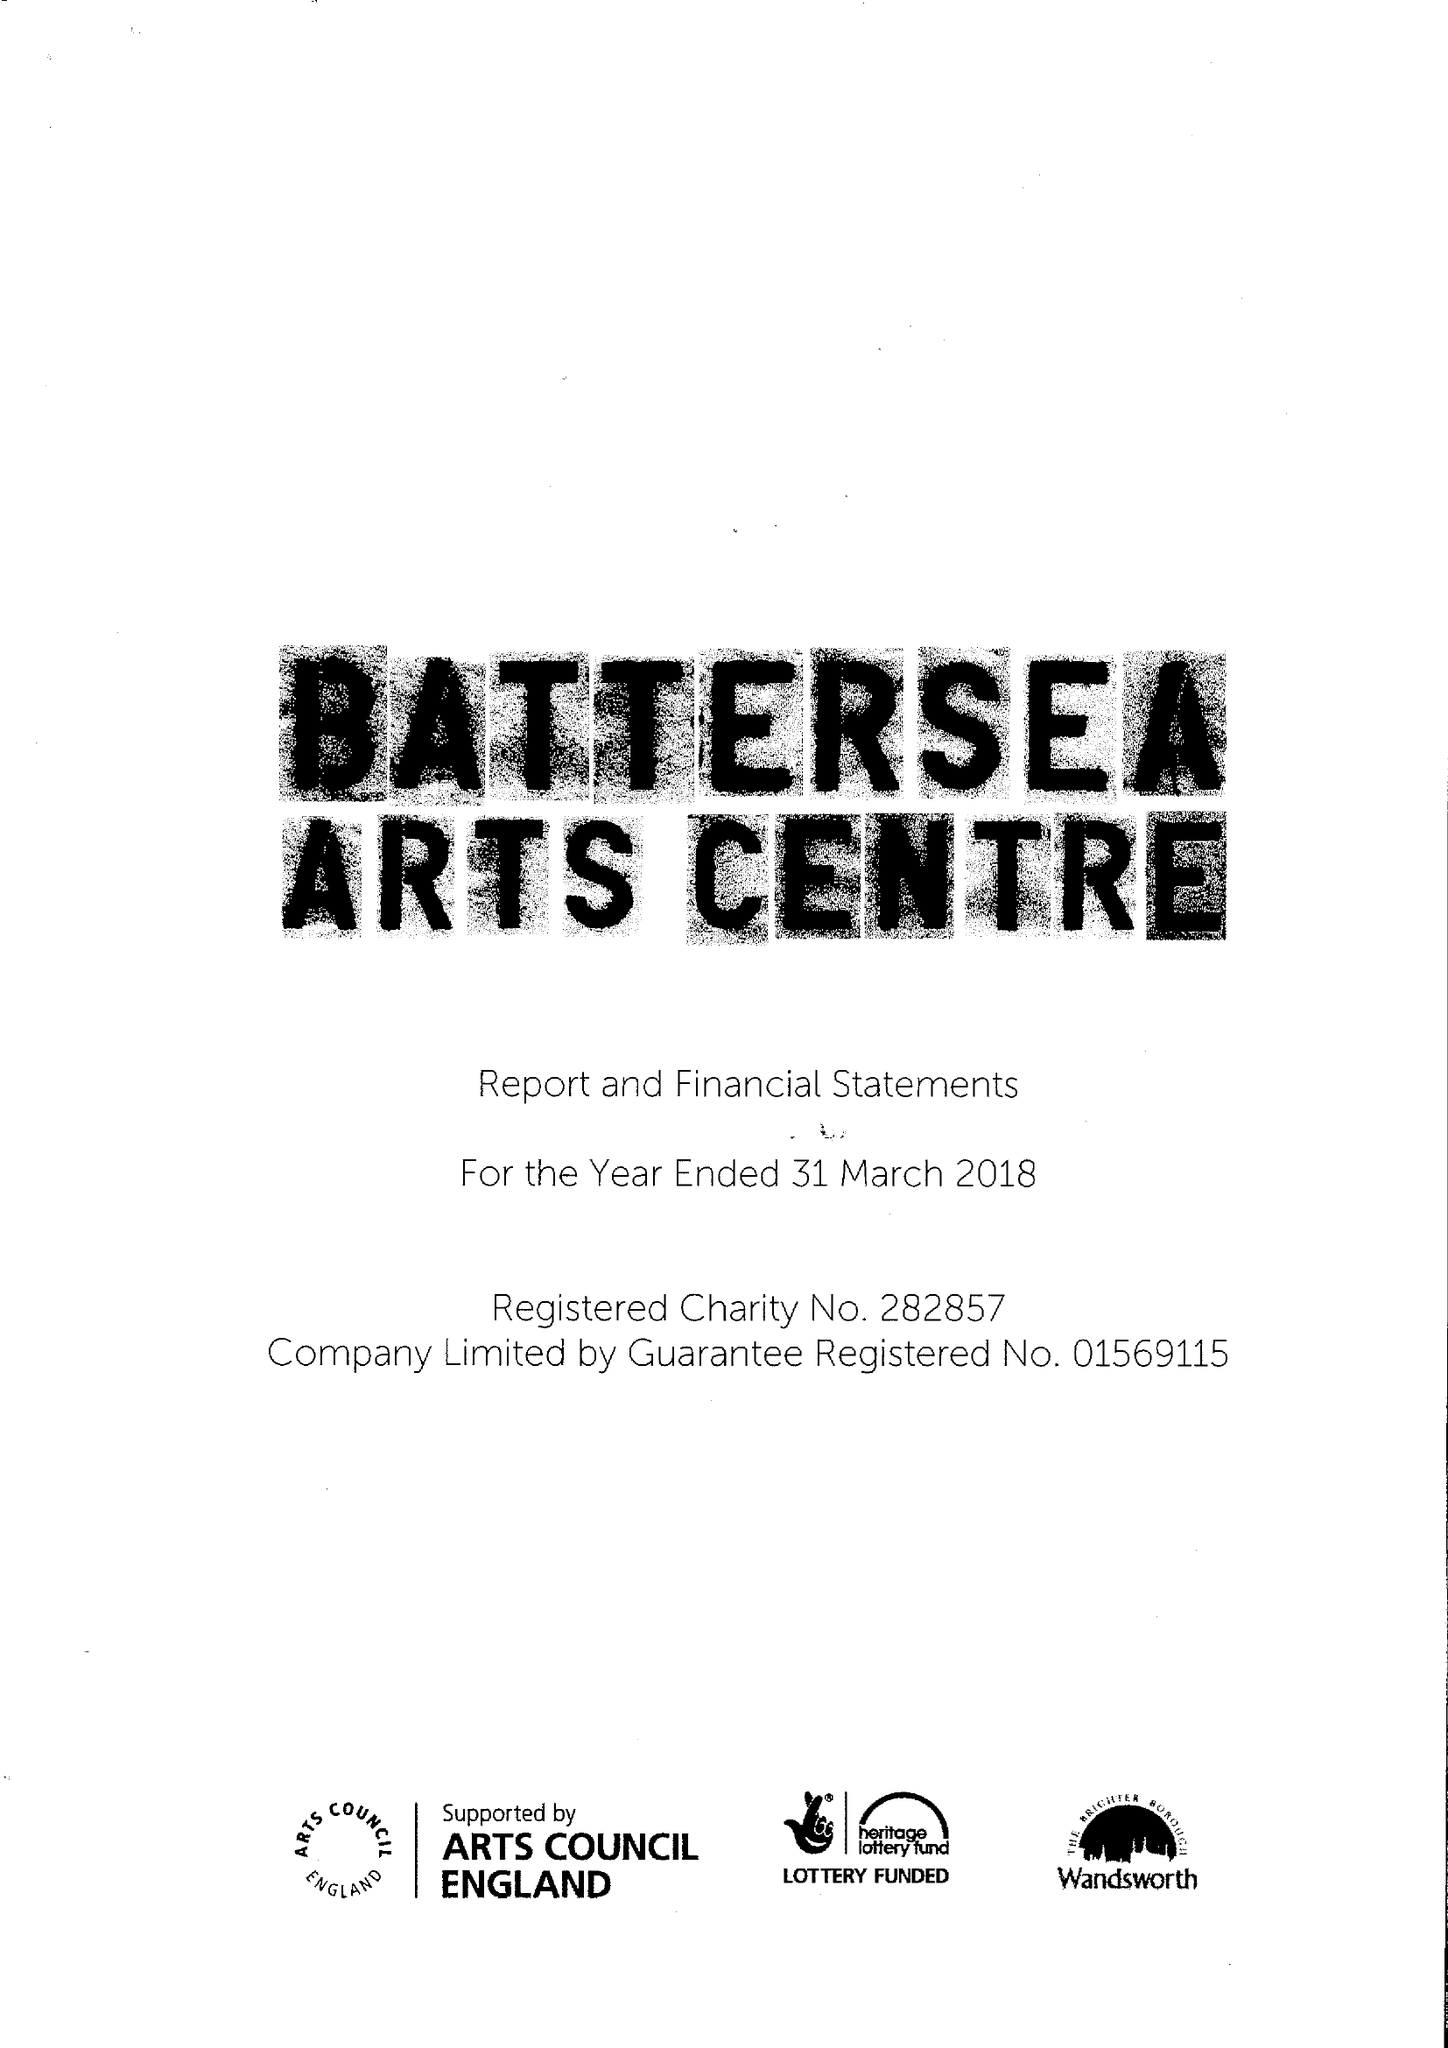What is the value for the charity_number?
Answer the question using a single word or phrase. 282857 